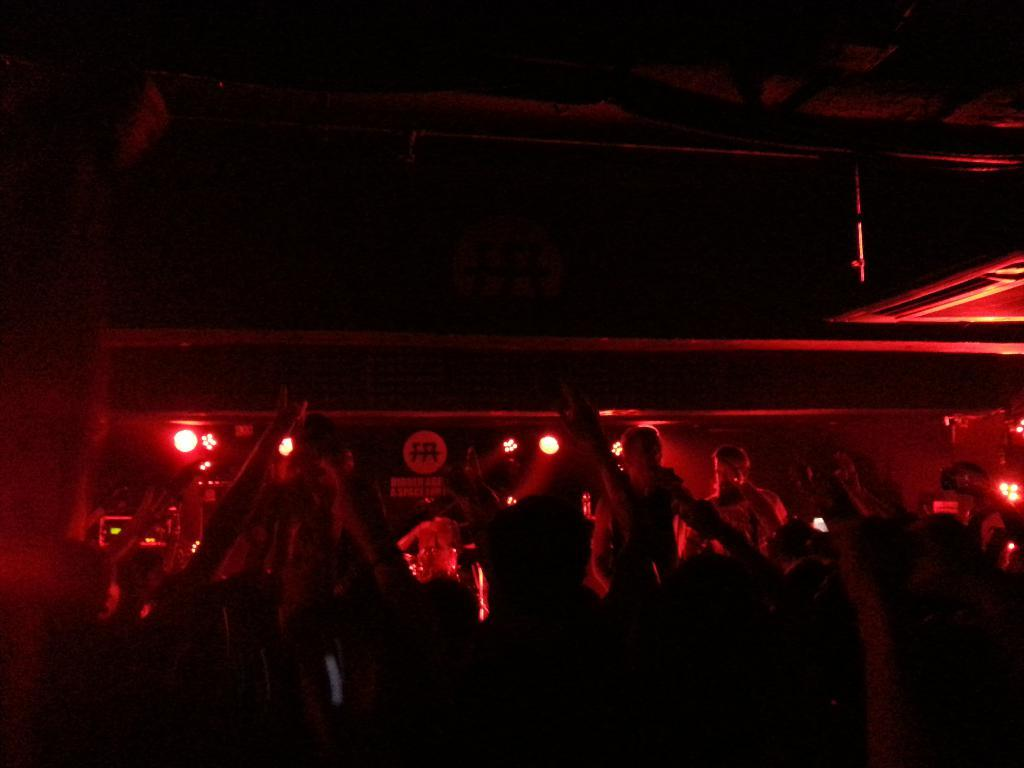How many people are in the image? There is a group of people in the image. What color are the lights in the background? There are red colored lights in the background. How would you describe the overall lighting in the image? The background of the image is dark. What type of reaction can be seen from the fan in the image? There is no fan present in the image. 